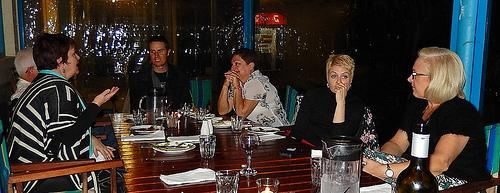How many individuals are sitting at the table in this image? There are seven individuals sitting at the table. Give a brief sentiment analysis of the image. The image evokes a sense of social interaction and bonding as people are gathered around a table, possibly sharing a meal or having a discussion. Please provide a detailed caption for this image. A group of seven people are sitting around a brown table filled with various objects such as plates, glasses, and a bottle, engaging in a conversation with one woman talking, while another woman faces away from the group with her arms on the table. What is the primary activity happening in the scene? A group of people are sitting around a table and engaging in a conversation. Enumerate the objects present on the table in the image. The brown table has plates, a bottle, several glasses, and a cup coaster on it. Assess the quality of the image based on the information provided. The image seems to be of high quality as it provides detailed information on the positions, sizes, and appearance of various objects and individuals in the scene. Perform a complex reasoning task by identifying the possible purpose of the gathering. The gathering may be a casual social event, a business meeting, or a shared meal, as evidenced by the presence of objects on the table, people conversing, and a woman not facing the group. Examine the interactions between the objects in the scene. The individuals appear to be interacting with each other and the objects on the table, such as plates, glasses, and a bottle, indicating a possible meal or social gathering. 